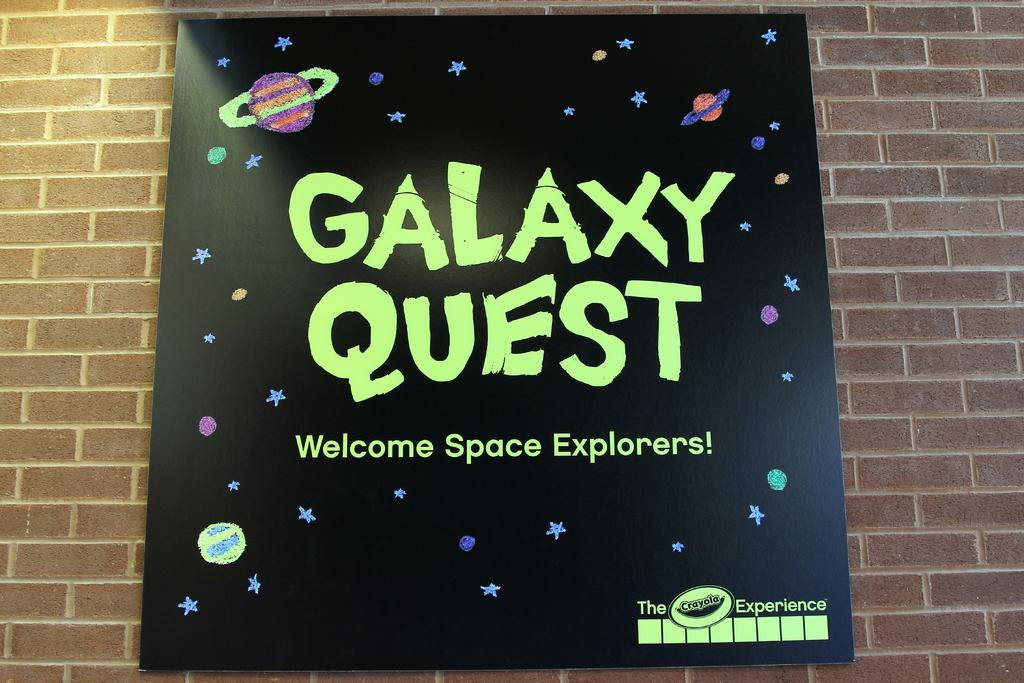<image>
Offer a succinct explanation of the picture presented. A black poster that says Galaxy Quest with star design and plants 